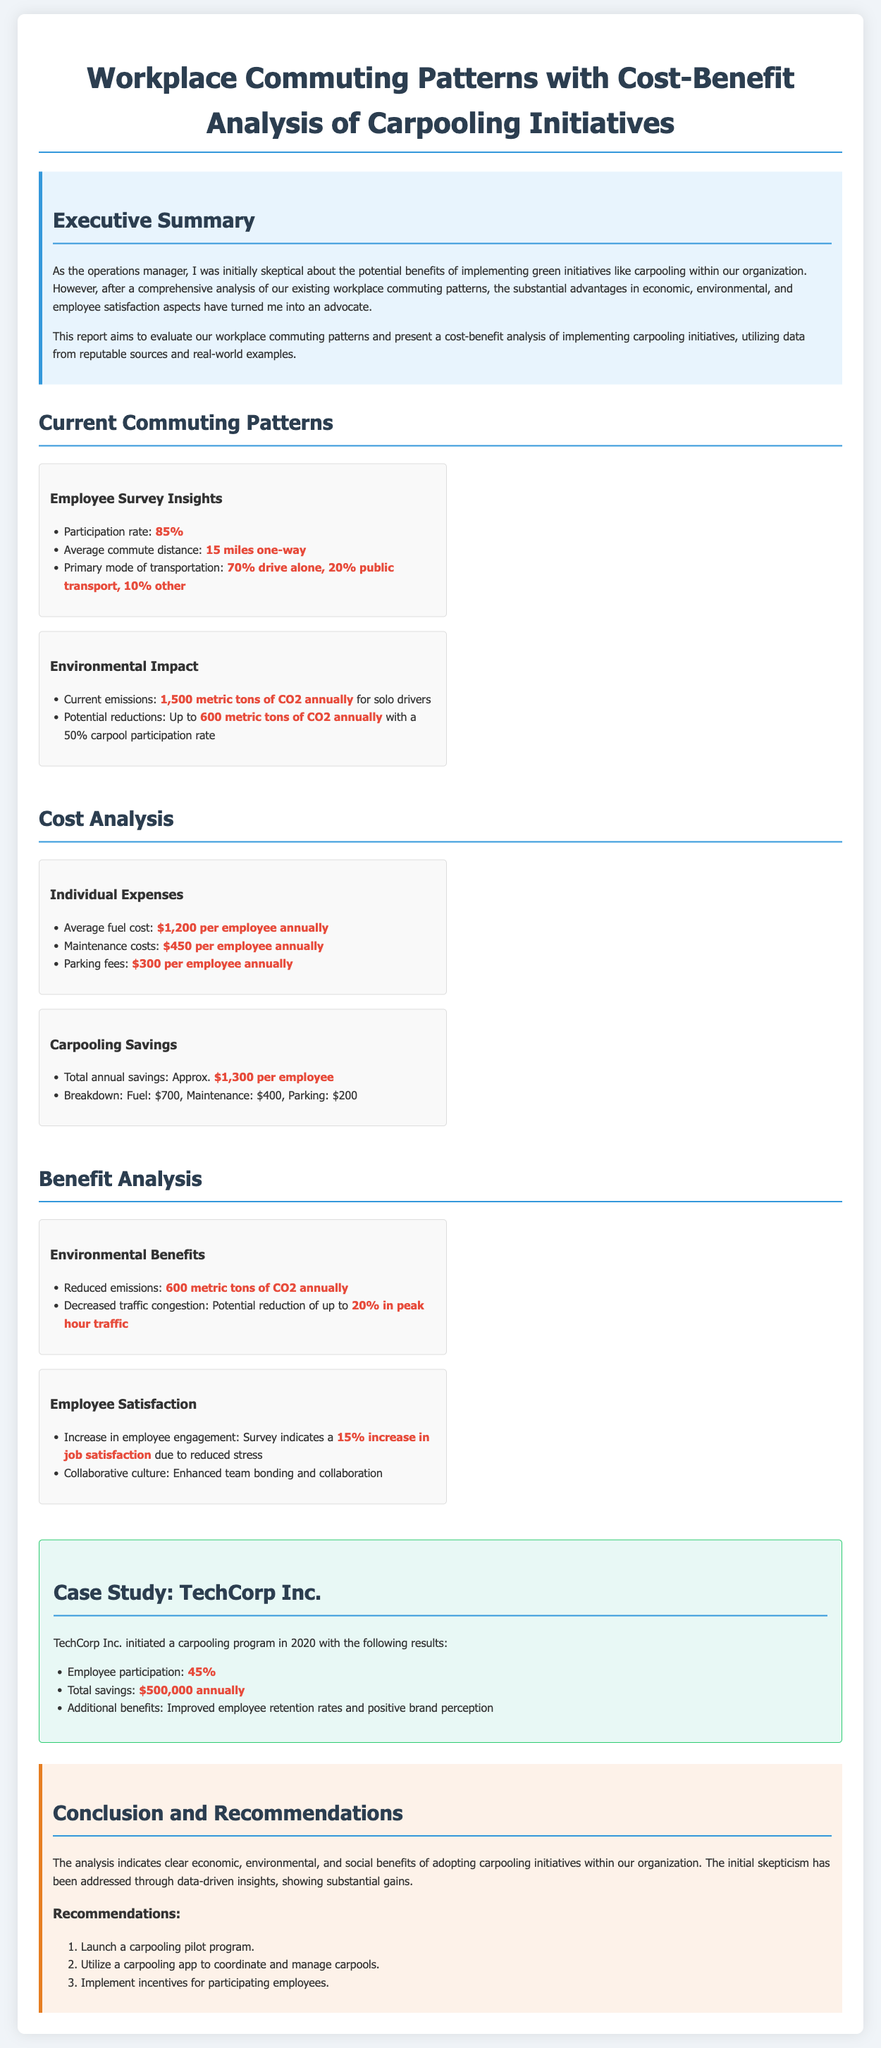What is the participation rate in the employee survey? The participation rate is specifically mentioned in the document as 85%.
Answer: 85% What is the average commute distance? The report states that the average commute distance is 15 miles one-way.
Answer: 15 miles one-way How much CO2 emissions can be potentially reduced with a 50% carpool participation rate? The document indicates that potential reductions could be up to 600 metric tons of CO2 annually.
Answer: 600 metric tons What is the total annual savings from carpooling per employee? The report outlines that the total annual savings from carpooling is approximately $1,300 per employee.
Answer: $1,300 What is one benefit of carpooling indicated in the employee satisfaction section? The report mentions an increase in job satisfaction by 15% due to reduced stress.
Answer: 15% increase in job satisfaction How much did TechCorp Inc. save annually with their carpooling program? According to the case study, TechCorp Inc. saved $500,000 annually with their carpooling program.
Answer: $500,000 What is the primary mode of transportation for employees? The document specifies that 70% of employees drive alone as their primary mode of transportation.
Answer: 70% drive alone What is one recommendation given in the conclusion? The report recommends launching a carpooling pilot program as one of its key initiatives.
Answer: Launch a carpooling pilot program What was the reduction potential of traffic congestion mentioned in the environmental benefits section? The potential reduction in traffic congestion during peak hours is stated to be up to 20%.
Answer: 20% 